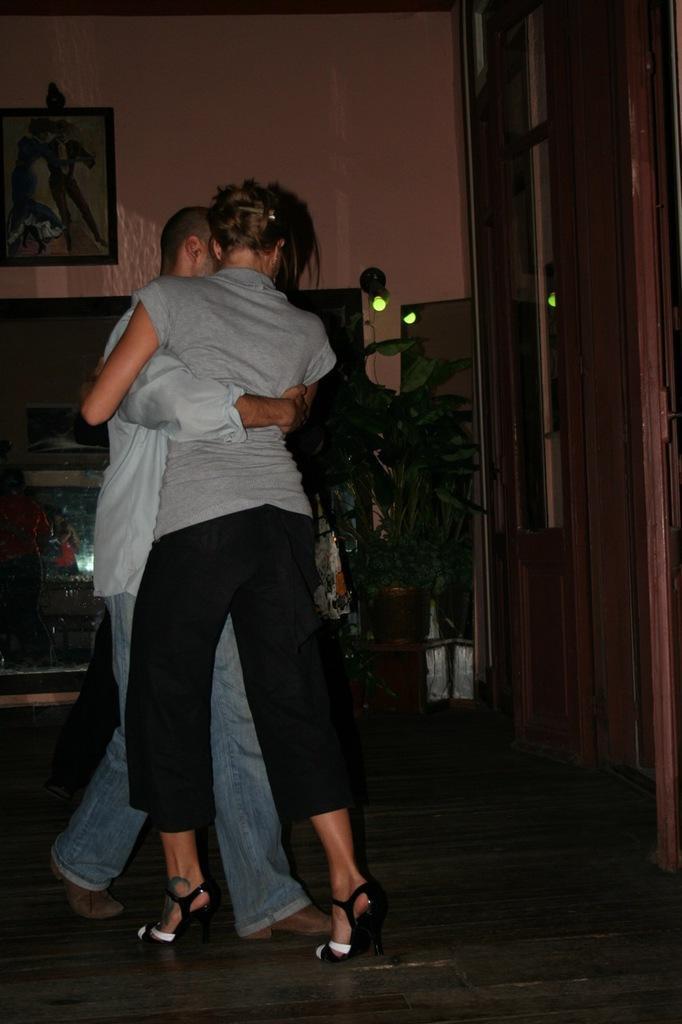In one or two sentences, can you explain what this image depicts? This image is taken indoors. At the bottom of the image there is a floor. In the background there is a wall with a picture frame and a door. In the background there is a television on the table and a plant in the pot. In the middle of the image a man and a woman are dancing on the floor. 